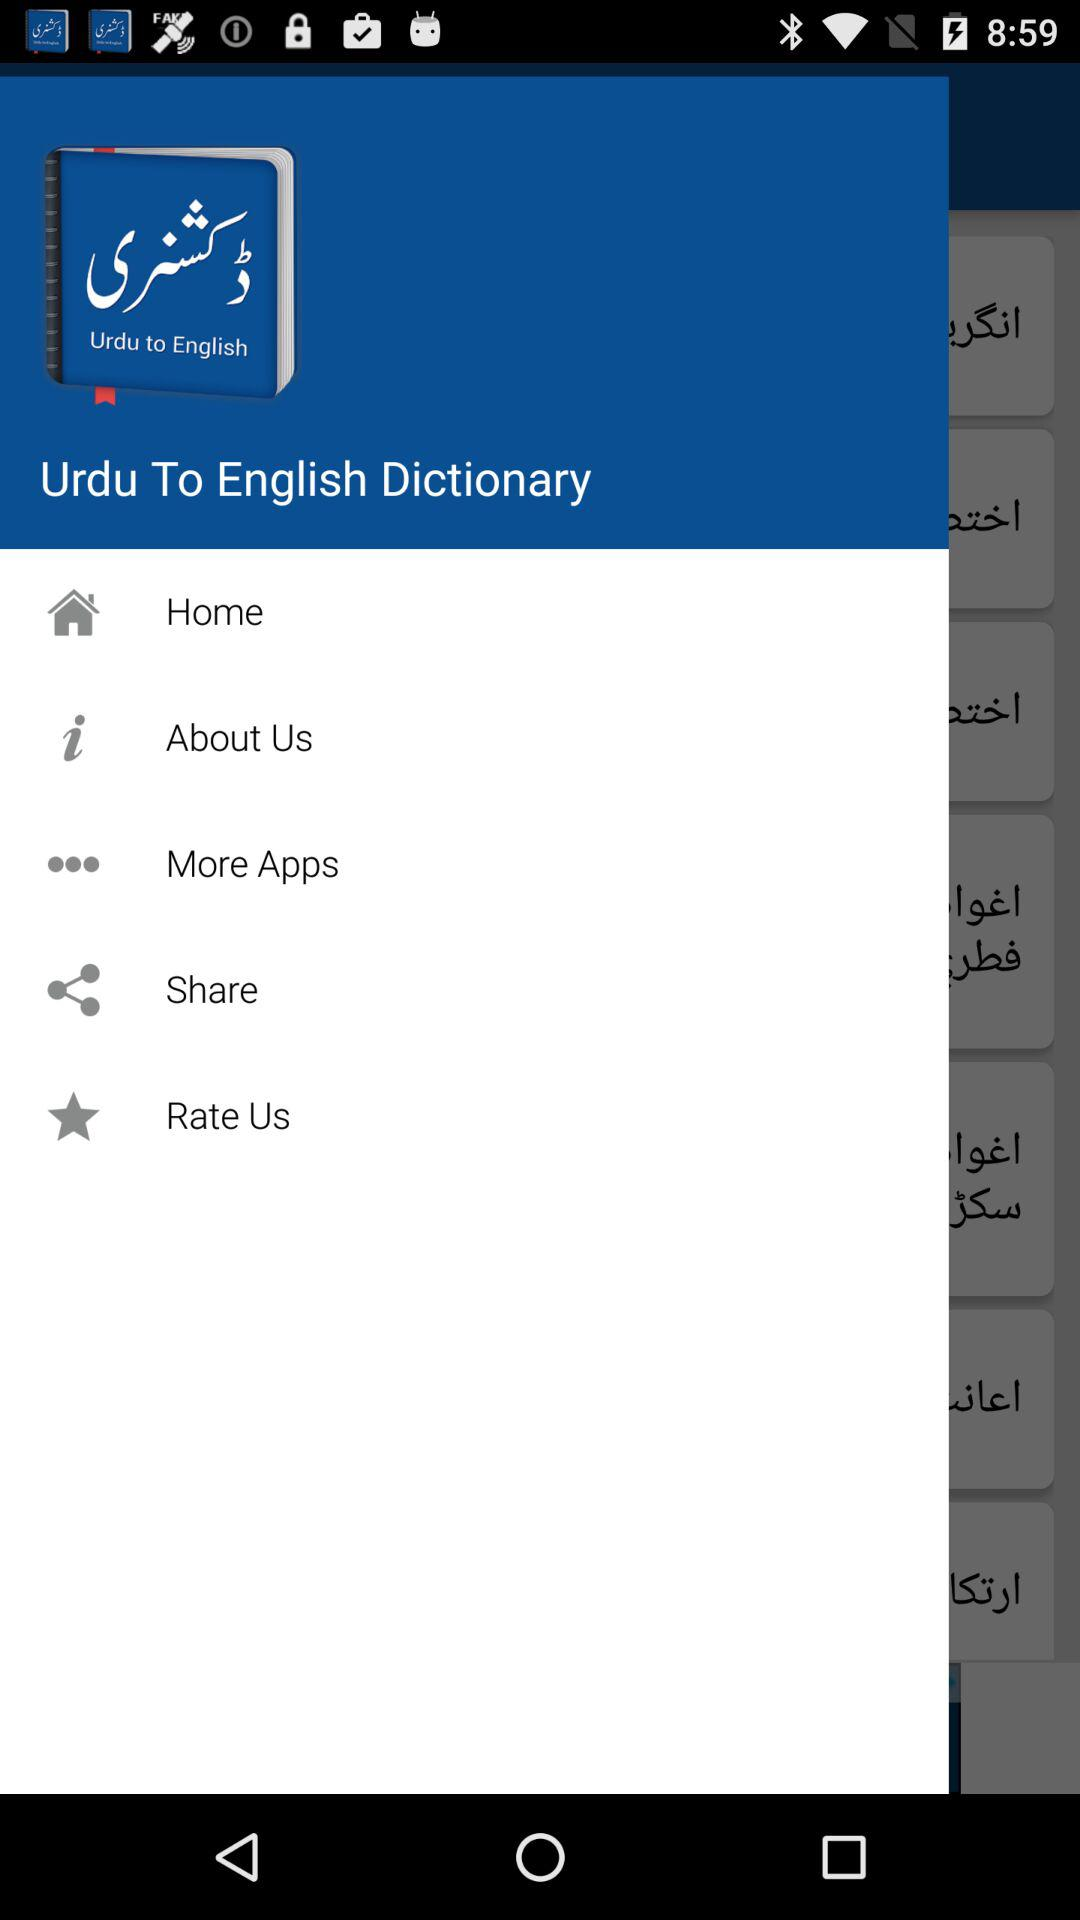What is the name of the application? The application name is "Urdu To English Dictionary". 